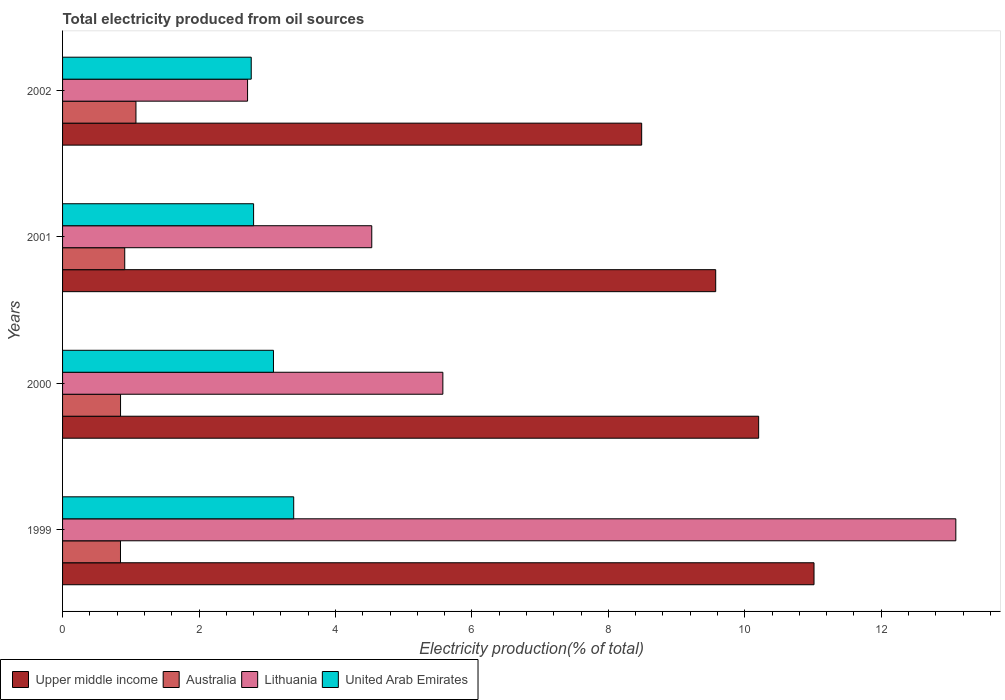How many bars are there on the 1st tick from the top?
Make the answer very short. 4. How many bars are there on the 4th tick from the bottom?
Your answer should be compact. 4. What is the label of the 2nd group of bars from the top?
Offer a terse response. 2001. In how many cases, is the number of bars for a given year not equal to the number of legend labels?
Give a very brief answer. 0. What is the total electricity produced in Australia in 2001?
Provide a succinct answer. 0.91. Across all years, what is the maximum total electricity produced in Lithuania?
Keep it short and to the point. 13.09. Across all years, what is the minimum total electricity produced in Australia?
Make the answer very short. 0.85. In which year was the total electricity produced in Lithuania minimum?
Your answer should be compact. 2002. What is the total total electricity produced in Australia in the graph?
Make the answer very short. 3.69. What is the difference between the total electricity produced in Australia in 1999 and that in 2002?
Your response must be concise. -0.23. What is the difference between the total electricity produced in Lithuania in 2000 and the total electricity produced in United Arab Emirates in 2002?
Make the answer very short. 2.81. What is the average total electricity produced in Upper middle income per year?
Offer a very short reply. 9.82. In the year 2000, what is the difference between the total electricity produced in Australia and total electricity produced in Lithuania?
Your answer should be compact. -4.72. In how many years, is the total electricity produced in United Arab Emirates greater than 12 %?
Offer a very short reply. 0. What is the ratio of the total electricity produced in Lithuania in 2000 to that in 2002?
Provide a succinct answer. 2.06. Is the difference between the total electricity produced in Australia in 1999 and 2002 greater than the difference between the total electricity produced in Lithuania in 1999 and 2002?
Your answer should be compact. No. What is the difference between the highest and the second highest total electricity produced in Lithuania?
Offer a terse response. 7.52. What is the difference between the highest and the lowest total electricity produced in Upper middle income?
Make the answer very short. 2.53. In how many years, is the total electricity produced in Lithuania greater than the average total electricity produced in Lithuania taken over all years?
Offer a terse response. 1. Is it the case that in every year, the sum of the total electricity produced in Lithuania and total electricity produced in United Arab Emirates is greater than the sum of total electricity produced in Upper middle income and total electricity produced in Australia?
Keep it short and to the point. No. What does the 1st bar from the top in 1999 represents?
Make the answer very short. United Arab Emirates. What does the 2nd bar from the bottom in 2000 represents?
Provide a short and direct response. Australia. Is it the case that in every year, the sum of the total electricity produced in United Arab Emirates and total electricity produced in Lithuania is greater than the total electricity produced in Upper middle income?
Keep it short and to the point. No. How many years are there in the graph?
Keep it short and to the point. 4. Does the graph contain grids?
Offer a very short reply. No. Where does the legend appear in the graph?
Make the answer very short. Bottom left. How many legend labels are there?
Make the answer very short. 4. What is the title of the graph?
Ensure brevity in your answer.  Total electricity produced from oil sources. Does "Small states" appear as one of the legend labels in the graph?
Offer a very short reply. No. What is the label or title of the Y-axis?
Provide a short and direct response. Years. What is the Electricity production(% of total) in Upper middle income in 1999?
Make the answer very short. 11.02. What is the Electricity production(% of total) in Australia in 1999?
Provide a succinct answer. 0.85. What is the Electricity production(% of total) in Lithuania in 1999?
Keep it short and to the point. 13.09. What is the Electricity production(% of total) of United Arab Emirates in 1999?
Your answer should be very brief. 3.39. What is the Electricity production(% of total) of Upper middle income in 2000?
Give a very brief answer. 10.2. What is the Electricity production(% of total) in Australia in 2000?
Provide a short and direct response. 0.85. What is the Electricity production(% of total) of Lithuania in 2000?
Provide a succinct answer. 5.58. What is the Electricity production(% of total) of United Arab Emirates in 2000?
Provide a short and direct response. 3.09. What is the Electricity production(% of total) of Upper middle income in 2001?
Make the answer very short. 9.57. What is the Electricity production(% of total) in Australia in 2001?
Make the answer very short. 0.91. What is the Electricity production(% of total) of Lithuania in 2001?
Offer a very short reply. 4.53. What is the Electricity production(% of total) in United Arab Emirates in 2001?
Your answer should be compact. 2.8. What is the Electricity production(% of total) in Upper middle income in 2002?
Your response must be concise. 8.49. What is the Electricity production(% of total) of Australia in 2002?
Your answer should be very brief. 1.08. What is the Electricity production(% of total) in Lithuania in 2002?
Ensure brevity in your answer.  2.71. What is the Electricity production(% of total) in United Arab Emirates in 2002?
Ensure brevity in your answer.  2.77. Across all years, what is the maximum Electricity production(% of total) in Upper middle income?
Ensure brevity in your answer.  11.02. Across all years, what is the maximum Electricity production(% of total) in Australia?
Your answer should be very brief. 1.08. Across all years, what is the maximum Electricity production(% of total) in Lithuania?
Your answer should be compact. 13.09. Across all years, what is the maximum Electricity production(% of total) in United Arab Emirates?
Your answer should be very brief. 3.39. Across all years, what is the minimum Electricity production(% of total) of Upper middle income?
Your answer should be compact. 8.49. Across all years, what is the minimum Electricity production(% of total) of Australia?
Your answer should be very brief. 0.85. Across all years, what is the minimum Electricity production(% of total) in Lithuania?
Offer a terse response. 2.71. Across all years, what is the minimum Electricity production(% of total) of United Arab Emirates?
Keep it short and to the point. 2.77. What is the total Electricity production(% of total) of Upper middle income in the graph?
Offer a terse response. 39.28. What is the total Electricity production(% of total) in Australia in the graph?
Provide a succinct answer. 3.69. What is the total Electricity production(% of total) of Lithuania in the graph?
Keep it short and to the point. 25.91. What is the total Electricity production(% of total) of United Arab Emirates in the graph?
Your answer should be very brief. 12.05. What is the difference between the Electricity production(% of total) of Upper middle income in 1999 and that in 2000?
Ensure brevity in your answer.  0.81. What is the difference between the Electricity production(% of total) of Australia in 1999 and that in 2000?
Make the answer very short. -0. What is the difference between the Electricity production(% of total) of Lithuania in 1999 and that in 2000?
Your answer should be compact. 7.52. What is the difference between the Electricity production(% of total) of United Arab Emirates in 1999 and that in 2000?
Keep it short and to the point. 0.3. What is the difference between the Electricity production(% of total) of Upper middle income in 1999 and that in 2001?
Your answer should be compact. 1.44. What is the difference between the Electricity production(% of total) in Australia in 1999 and that in 2001?
Ensure brevity in your answer.  -0.06. What is the difference between the Electricity production(% of total) of Lithuania in 1999 and that in 2001?
Your response must be concise. 8.56. What is the difference between the Electricity production(% of total) of United Arab Emirates in 1999 and that in 2001?
Keep it short and to the point. 0.59. What is the difference between the Electricity production(% of total) of Upper middle income in 1999 and that in 2002?
Offer a very short reply. 2.53. What is the difference between the Electricity production(% of total) in Australia in 1999 and that in 2002?
Your answer should be compact. -0.23. What is the difference between the Electricity production(% of total) of Lithuania in 1999 and that in 2002?
Make the answer very short. 10.38. What is the difference between the Electricity production(% of total) in United Arab Emirates in 1999 and that in 2002?
Provide a short and direct response. 0.62. What is the difference between the Electricity production(% of total) in Upper middle income in 2000 and that in 2001?
Keep it short and to the point. 0.63. What is the difference between the Electricity production(% of total) of Australia in 2000 and that in 2001?
Ensure brevity in your answer.  -0.06. What is the difference between the Electricity production(% of total) in Lithuania in 2000 and that in 2001?
Provide a short and direct response. 1.04. What is the difference between the Electricity production(% of total) of United Arab Emirates in 2000 and that in 2001?
Provide a succinct answer. 0.29. What is the difference between the Electricity production(% of total) of Upper middle income in 2000 and that in 2002?
Offer a terse response. 1.71. What is the difference between the Electricity production(% of total) in Australia in 2000 and that in 2002?
Ensure brevity in your answer.  -0.23. What is the difference between the Electricity production(% of total) in Lithuania in 2000 and that in 2002?
Provide a short and direct response. 2.86. What is the difference between the Electricity production(% of total) in United Arab Emirates in 2000 and that in 2002?
Your response must be concise. 0.33. What is the difference between the Electricity production(% of total) in Upper middle income in 2001 and that in 2002?
Offer a terse response. 1.09. What is the difference between the Electricity production(% of total) of Australia in 2001 and that in 2002?
Offer a terse response. -0.16. What is the difference between the Electricity production(% of total) of Lithuania in 2001 and that in 2002?
Give a very brief answer. 1.82. What is the difference between the Electricity production(% of total) of United Arab Emirates in 2001 and that in 2002?
Give a very brief answer. 0.03. What is the difference between the Electricity production(% of total) of Upper middle income in 1999 and the Electricity production(% of total) of Australia in 2000?
Keep it short and to the point. 10.17. What is the difference between the Electricity production(% of total) of Upper middle income in 1999 and the Electricity production(% of total) of Lithuania in 2000?
Ensure brevity in your answer.  5.44. What is the difference between the Electricity production(% of total) in Upper middle income in 1999 and the Electricity production(% of total) in United Arab Emirates in 2000?
Offer a terse response. 7.92. What is the difference between the Electricity production(% of total) of Australia in 1999 and the Electricity production(% of total) of Lithuania in 2000?
Offer a terse response. -4.73. What is the difference between the Electricity production(% of total) in Australia in 1999 and the Electricity production(% of total) in United Arab Emirates in 2000?
Make the answer very short. -2.24. What is the difference between the Electricity production(% of total) in Lithuania in 1999 and the Electricity production(% of total) in United Arab Emirates in 2000?
Provide a short and direct response. 10. What is the difference between the Electricity production(% of total) in Upper middle income in 1999 and the Electricity production(% of total) in Australia in 2001?
Keep it short and to the point. 10.1. What is the difference between the Electricity production(% of total) of Upper middle income in 1999 and the Electricity production(% of total) of Lithuania in 2001?
Keep it short and to the point. 6.48. What is the difference between the Electricity production(% of total) in Upper middle income in 1999 and the Electricity production(% of total) in United Arab Emirates in 2001?
Keep it short and to the point. 8.22. What is the difference between the Electricity production(% of total) in Australia in 1999 and the Electricity production(% of total) in Lithuania in 2001?
Provide a succinct answer. -3.68. What is the difference between the Electricity production(% of total) of Australia in 1999 and the Electricity production(% of total) of United Arab Emirates in 2001?
Offer a very short reply. -1.95. What is the difference between the Electricity production(% of total) in Lithuania in 1999 and the Electricity production(% of total) in United Arab Emirates in 2001?
Your answer should be very brief. 10.29. What is the difference between the Electricity production(% of total) of Upper middle income in 1999 and the Electricity production(% of total) of Australia in 2002?
Your answer should be compact. 9.94. What is the difference between the Electricity production(% of total) in Upper middle income in 1999 and the Electricity production(% of total) in Lithuania in 2002?
Provide a succinct answer. 8.3. What is the difference between the Electricity production(% of total) in Upper middle income in 1999 and the Electricity production(% of total) in United Arab Emirates in 2002?
Offer a very short reply. 8.25. What is the difference between the Electricity production(% of total) of Australia in 1999 and the Electricity production(% of total) of Lithuania in 2002?
Your answer should be very brief. -1.86. What is the difference between the Electricity production(% of total) of Australia in 1999 and the Electricity production(% of total) of United Arab Emirates in 2002?
Your response must be concise. -1.92. What is the difference between the Electricity production(% of total) in Lithuania in 1999 and the Electricity production(% of total) in United Arab Emirates in 2002?
Your answer should be compact. 10.33. What is the difference between the Electricity production(% of total) of Upper middle income in 2000 and the Electricity production(% of total) of Australia in 2001?
Your response must be concise. 9.29. What is the difference between the Electricity production(% of total) in Upper middle income in 2000 and the Electricity production(% of total) in Lithuania in 2001?
Your answer should be very brief. 5.67. What is the difference between the Electricity production(% of total) of Upper middle income in 2000 and the Electricity production(% of total) of United Arab Emirates in 2001?
Make the answer very short. 7.4. What is the difference between the Electricity production(% of total) of Australia in 2000 and the Electricity production(% of total) of Lithuania in 2001?
Provide a succinct answer. -3.68. What is the difference between the Electricity production(% of total) in Australia in 2000 and the Electricity production(% of total) in United Arab Emirates in 2001?
Make the answer very short. -1.95. What is the difference between the Electricity production(% of total) of Lithuania in 2000 and the Electricity production(% of total) of United Arab Emirates in 2001?
Offer a terse response. 2.77. What is the difference between the Electricity production(% of total) of Upper middle income in 2000 and the Electricity production(% of total) of Australia in 2002?
Provide a succinct answer. 9.13. What is the difference between the Electricity production(% of total) in Upper middle income in 2000 and the Electricity production(% of total) in Lithuania in 2002?
Your answer should be very brief. 7.49. What is the difference between the Electricity production(% of total) in Upper middle income in 2000 and the Electricity production(% of total) in United Arab Emirates in 2002?
Offer a terse response. 7.44. What is the difference between the Electricity production(% of total) of Australia in 2000 and the Electricity production(% of total) of Lithuania in 2002?
Make the answer very short. -1.86. What is the difference between the Electricity production(% of total) of Australia in 2000 and the Electricity production(% of total) of United Arab Emirates in 2002?
Your answer should be very brief. -1.92. What is the difference between the Electricity production(% of total) in Lithuania in 2000 and the Electricity production(% of total) in United Arab Emirates in 2002?
Your response must be concise. 2.81. What is the difference between the Electricity production(% of total) of Upper middle income in 2001 and the Electricity production(% of total) of Australia in 2002?
Provide a succinct answer. 8.5. What is the difference between the Electricity production(% of total) of Upper middle income in 2001 and the Electricity production(% of total) of Lithuania in 2002?
Offer a terse response. 6.86. What is the difference between the Electricity production(% of total) in Upper middle income in 2001 and the Electricity production(% of total) in United Arab Emirates in 2002?
Provide a short and direct response. 6.81. What is the difference between the Electricity production(% of total) in Australia in 2001 and the Electricity production(% of total) in Lithuania in 2002?
Your response must be concise. -1.8. What is the difference between the Electricity production(% of total) of Australia in 2001 and the Electricity production(% of total) of United Arab Emirates in 2002?
Offer a terse response. -1.85. What is the difference between the Electricity production(% of total) in Lithuania in 2001 and the Electricity production(% of total) in United Arab Emirates in 2002?
Your answer should be compact. 1.77. What is the average Electricity production(% of total) of Upper middle income per year?
Keep it short and to the point. 9.82. What is the average Electricity production(% of total) of Australia per year?
Make the answer very short. 0.92. What is the average Electricity production(% of total) in Lithuania per year?
Make the answer very short. 6.48. What is the average Electricity production(% of total) in United Arab Emirates per year?
Offer a very short reply. 3.01. In the year 1999, what is the difference between the Electricity production(% of total) in Upper middle income and Electricity production(% of total) in Australia?
Keep it short and to the point. 10.17. In the year 1999, what is the difference between the Electricity production(% of total) of Upper middle income and Electricity production(% of total) of Lithuania?
Give a very brief answer. -2.08. In the year 1999, what is the difference between the Electricity production(% of total) in Upper middle income and Electricity production(% of total) in United Arab Emirates?
Provide a short and direct response. 7.63. In the year 1999, what is the difference between the Electricity production(% of total) of Australia and Electricity production(% of total) of Lithuania?
Keep it short and to the point. -12.25. In the year 1999, what is the difference between the Electricity production(% of total) in Australia and Electricity production(% of total) in United Arab Emirates?
Offer a terse response. -2.54. In the year 1999, what is the difference between the Electricity production(% of total) in Lithuania and Electricity production(% of total) in United Arab Emirates?
Provide a succinct answer. 9.71. In the year 2000, what is the difference between the Electricity production(% of total) of Upper middle income and Electricity production(% of total) of Australia?
Make the answer very short. 9.35. In the year 2000, what is the difference between the Electricity production(% of total) of Upper middle income and Electricity production(% of total) of Lithuania?
Provide a short and direct response. 4.63. In the year 2000, what is the difference between the Electricity production(% of total) in Upper middle income and Electricity production(% of total) in United Arab Emirates?
Offer a very short reply. 7.11. In the year 2000, what is the difference between the Electricity production(% of total) in Australia and Electricity production(% of total) in Lithuania?
Give a very brief answer. -4.72. In the year 2000, what is the difference between the Electricity production(% of total) in Australia and Electricity production(% of total) in United Arab Emirates?
Make the answer very short. -2.24. In the year 2000, what is the difference between the Electricity production(% of total) of Lithuania and Electricity production(% of total) of United Arab Emirates?
Keep it short and to the point. 2.48. In the year 2001, what is the difference between the Electricity production(% of total) in Upper middle income and Electricity production(% of total) in Australia?
Your answer should be very brief. 8.66. In the year 2001, what is the difference between the Electricity production(% of total) of Upper middle income and Electricity production(% of total) of Lithuania?
Your response must be concise. 5.04. In the year 2001, what is the difference between the Electricity production(% of total) of Upper middle income and Electricity production(% of total) of United Arab Emirates?
Your response must be concise. 6.77. In the year 2001, what is the difference between the Electricity production(% of total) in Australia and Electricity production(% of total) in Lithuania?
Provide a short and direct response. -3.62. In the year 2001, what is the difference between the Electricity production(% of total) in Australia and Electricity production(% of total) in United Arab Emirates?
Make the answer very short. -1.89. In the year 2001, what is the difference between the Electricity production(% of total) of Lithuania and Electricity production(% of total) of United Arab Emirates?
Provide a short and direct response. 1.73. In the year 2002, what is the difference between the Electricity production(% of total) of Upper middle income and Electricity production(% of total) of Australia?
Keep it short and to the point. 7.41. In the year 2002, what is the difference between the Electricity production(% of total) of Upper middle income and Electricity production(% of total) of Lithuania?
Provide a short and direct response. 5.78. In the year 2002, what is the difference between the Electricity production(% of total) in Upper middle income and Electricity production(% of total) in United Arab Emirates?
Ensure brevity in your answer.  5.72. In the year 2002, what is the difference between the Electricity production(% of total) in Australia and Electricity production(% of total) in Lithuania?
Provide a short and direct response. -1.64. In the year 2002, what is the difference between the Electricity production(% of total) of Australia and Electricity production(% of total) of United Arab Emirates?
Offer a very short reply. -1.69. In the year 2002, what is the difference between the Electricity production(% of total) in Lithuania and Electricity production(% of total) in United Arab Emirates?
Provide a short and direct response. -0.05. What is the ratio of the Electricity production(% of total) of Upper middle income in 1999 to that in 2000?
Offer a very short reply. 1.08. What is the ratio of the Electricity production(% of total) of Lithuania in 1999 to that in 2000?
Ensure brevity in your answer.  2.35. What is the ratio of the Electricity production(% of total) in United Arab Emirates in 1999 to that in 2000?
Offer a very short reply. 1.1. What is the ratio of the Electricity production(% of total) in Upper middle income in 1999 to that in 2001?
Ensure brevity in your answer.  1.15. What is the ratio of the Electricity production(% of total) of Australia in 1999 to that in 2001?
Offer a very short reply. 0.93. What is the ratio of the Electricity production(% of total) in Lithuania in 1999 to that in 2001?
Give a very brief answer. 2.89. What is the ratio of the Electricity production(% of total) of United Arab Emirates in 1999 to that in 2001?
Ensure brevity in your answer.  1.21. What is the ratio of the Electricity production(% of total) in Upper middle income in 1999 to that in 2002?
Provide a succinct answer. 1.3. What is the ratio of the Electricity production(% of total) in Australia in 1999 to that in 2002?
Your answer should be very brief. 0.79. What is the ratio of the Electricity production(% of total) in Lithuania in 1999 to that in 2002?
Keep it short and to the point. 4.83. What is the ratio of the Electricity production(% of total) of United Arab Emirates in 1999 to that in 2002?
Ensure brevity in your answer.  1.23. What is the ratio of the Electricity production(% of total) in Upper middle income in 2000 to that in 2001?
Make the answer very short. 1.07. What is the ratio of the Electricity production(% of total) of Australia in 2000 to that in 2001?
Ensure brevity in your answer.  0.93. What is the ratio of the Electricity production(% of total) of Lithuania in 2000 to that in 2001?
Make the answer very short. 1.23. What is the ratio of the Electricity production(% of total) in United Arab Emirates in 2000 to that in 2001?
Offer a very short reply. 1.1. What is the ratio of the Electricity production(% of total) of Upper middle income in 2000 to that in 2002?
Make the answer very short. 1.2. What is the ratio of the Electricity production(% of total) of Australia in 2000 to that in 2002?
Offer a terse response. 0.79. What is the ratio of the Electricity production(% of total) of Lithuania in 2000 to that in 2002?
Give a very brief answer. 2.06. What is the ratio of the Electricity production(% of total) of United Arab Emirates in 2000 to that in 2002?
Offer a terse response. 1.12. What is the ratio of the Electricity production(% of total) in Upper middle income in 2001 to that in 2002?
Your response must be concise. 1.13. What is the ratio of the Electricity production(% of total) in Australia in 2001 to that in 2002?
Make the answer very short. 0.85. What is the ratio of the Electricity production(% of total) in Lithuania in 2001 to that in 2002?
Make the answer very short. 1.67. What is the ratio of the Electricity production(% of total) of United Arab Emirates in 2001 to that in 2002?
Your answer should be compact. 1.01. What is the difference between the highest and the second highest Electricity production(% of total) in Upper middle income?
Keep it short and to the point. 0.81. What is the difference between the highest and the second highest Electricity production(% of total) in Australia?
Offer a terse response. 0.16. What is the difference between the highest and the second highest Electricity production(% of total) of Lithuania?
Provide a succinct answer. 7.52. What is the difference between the highest and the second highest Electricity production(% of total) in United Arab Emirates?
Make the answer very short. 0.3. What is the difference between the highest and the lowest Electricity production(% of total) in Upper middle income?
Offer a very short reply. 2.53. What is the difference between the highest and the lowest Electricity production(% of total) of Australia?
Make the answer very short. 0.23. What is the difference between the highest and the lowest Electricity production(% of total) of Lithuania?
Offer a very short reply. 10.38. What is the difference between the highest and the lowest Electricity production(% of total) of United Arab Emirates?
Give a very brief answer. 0.62. 